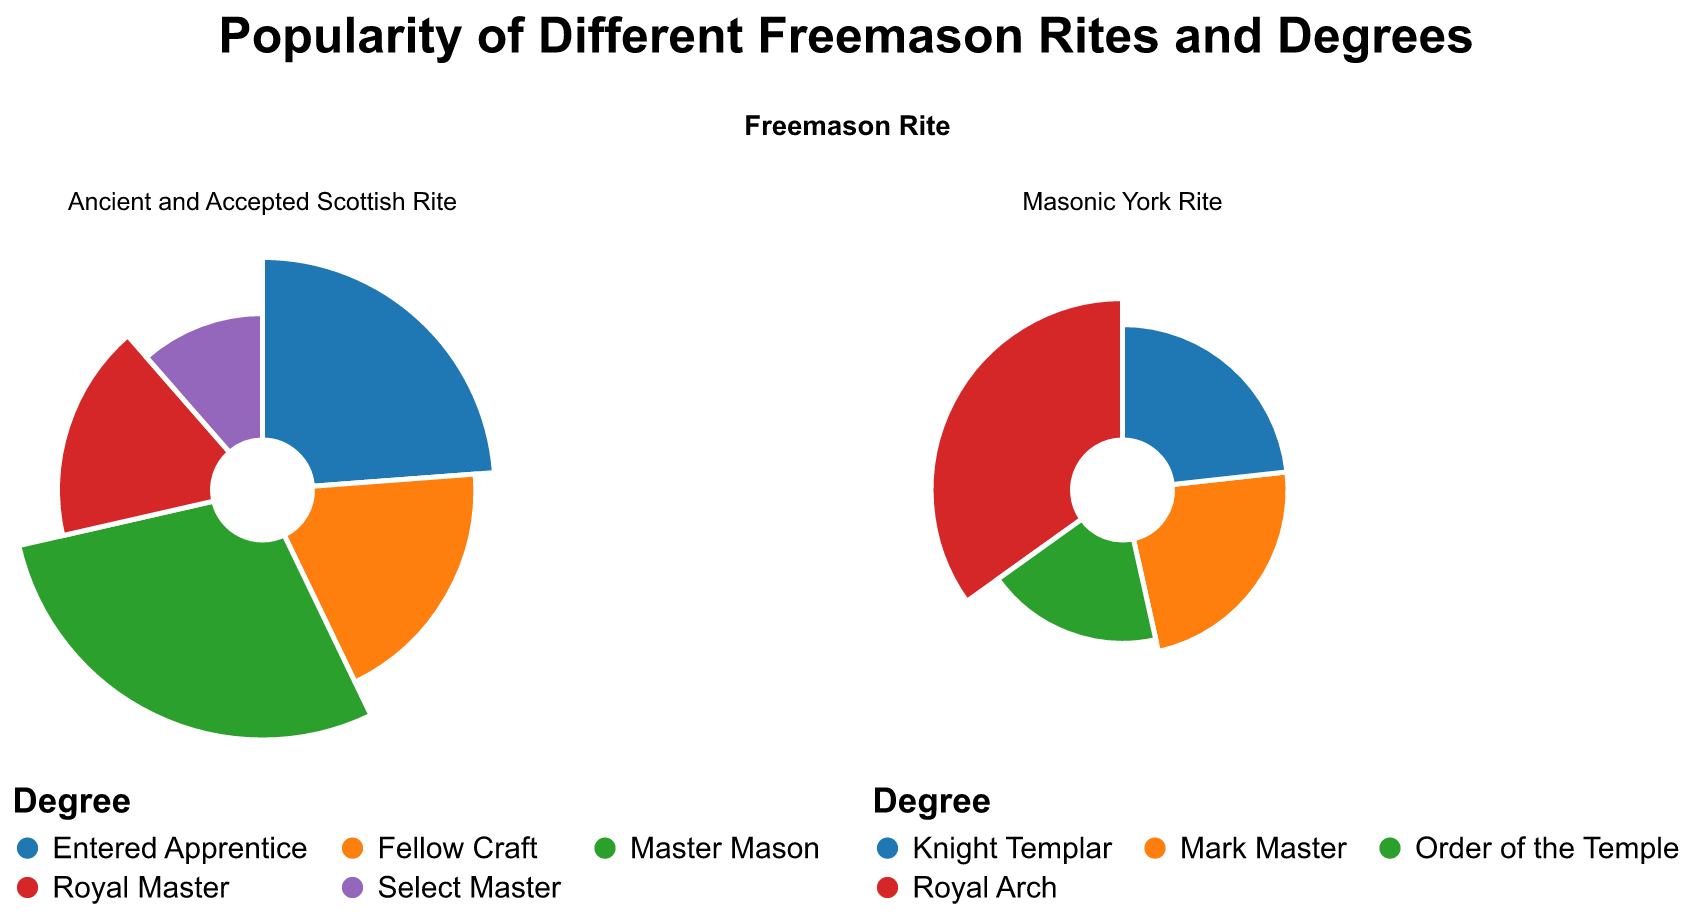What's the title of the figure? The title is generally located at the top of the figure. In this plot, it states the overall subject being visualized. The title here is "Popularity of Different Freemason Rites and Degrees."
Answer: Popularity of Different Freemason Rites and Degrees How many Freemason Rites are represented in the plot? By examining the column labels in the faceted subplots, you can count the different rites mentioned. There are "Ancient and Accepted Scottish Rite" and "Masonic York Rite."
Answer: 2 Which degree has the highest percentage in the Ancient and Accepted Scottish Rite? Look at the radial segments within the Ancient and Accepted Scottish Rite subplot, and identify the segment with the largest angle and radius. This corresponds to "Master Mason" with a percentage of 30.
Answer: Master Mason What's the combined percentage for all degrees under the Masonic York Rite? Sum the percentages for all the degrees within the Masonic York Rite subplot. The degrees are Mark Master (10%), Royal Arch (15%), Order of the Temple (8%), and Knight Templar (10%). Summing these up, 10 + 15 + 8 + 10 = 43.
Answer: 43 Compare the percentage of Member Master degrees between the two rites. The Member Master degree belongs to "Master Mason" in the Ancient and Accepted Scottish Rite (30%) and "Mark Master" (10%) in the Masonic York Rite.
Answer: The percentage for Master Mason is greater by 20 Which degree has the smallest representation in the Masonic York Rite? The degree with the smallest angular section in the Masonic York Rite subplot has the smallest percentage. This belongs to "Order of the Temple," which is 8%.
Answer: Order of the Temple How does the percentage of Entered Apprentice compare to Fellow Craft in the Ancient and Accepted Scottish Rite? In the Ancient and Accepted Scottish Rite subplot, compare the percentage values of Entered Apprentice (25%) and Fellow Craft (20%).
Answer: Entered Apprentice is higher by 5% What is the average percentage of the degrees within the Ancient and Accepted Scottish Rite? Sum the percentages of the degrees within the Ancient and Accepted Scottish Rite (25+20+30+18+12) = 105, then divide by the number of degrees (5). 105/5 = 21
Answer: 21 How many degrees have a percentage above 10 in the Ancient and Accepted Scottish Rite? Count the degrees in the Ancient and Accepted Scottish Rite subplot that have a percentage value greater than 10. These are Entered Apprentice (25%), Fellow Craft (20%), Master Mason (30%), Royal Master (18%), and Select Master (12%).
Answer: 5 